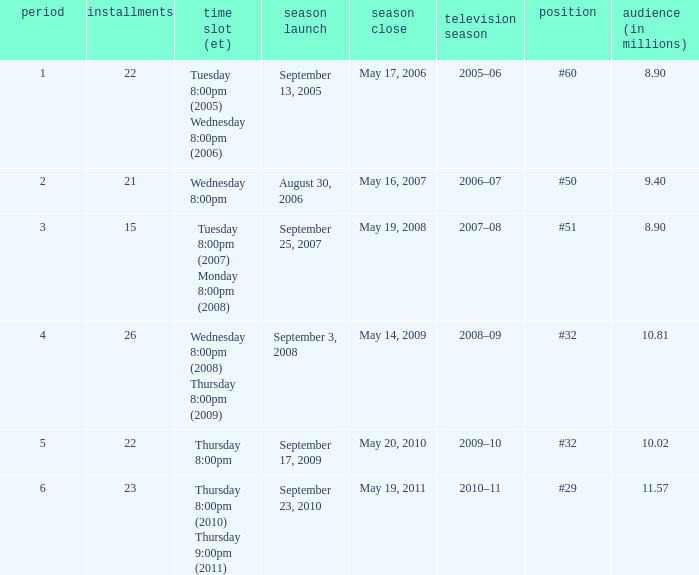How many seasons was the rank equal to #50? 1.0. 